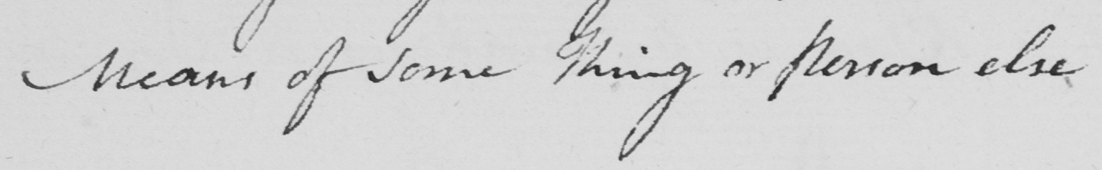Can you read and transcribe this handwriting? means of some thing or person else 